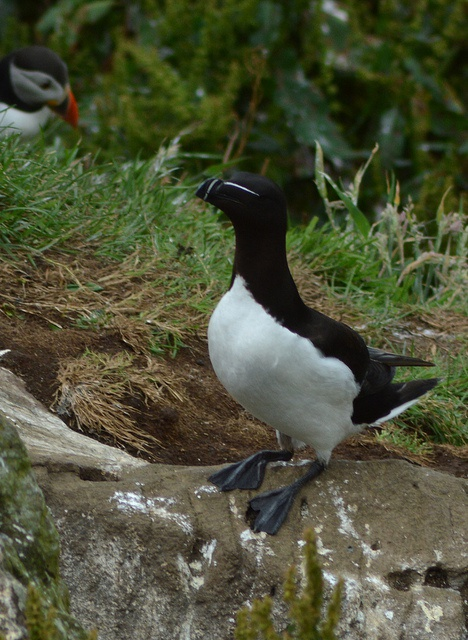Describe the objects in this image and their specific colors. I can see bird in black, gray, darkgray, and lightblue tones and bird in black, gray, darkgray, and maroon tones in this image. 